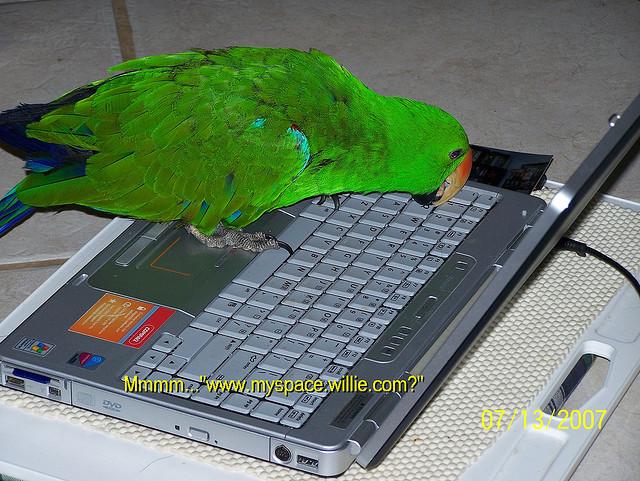What kind of bird is this?
Write a very short answer. Parrot. What is the bird doing?
Keep it brief. Typing. Do you see a laptop?
Answer briefly. Yes. 